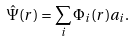Convert formula to latex. <formula><loc_0><loc_0><loc_500><loc_500>\hat { \Psi } ( { r } ) = \sum _ { i } \Phi _ { i } ( { r } ) a _ { i } .</formula> 